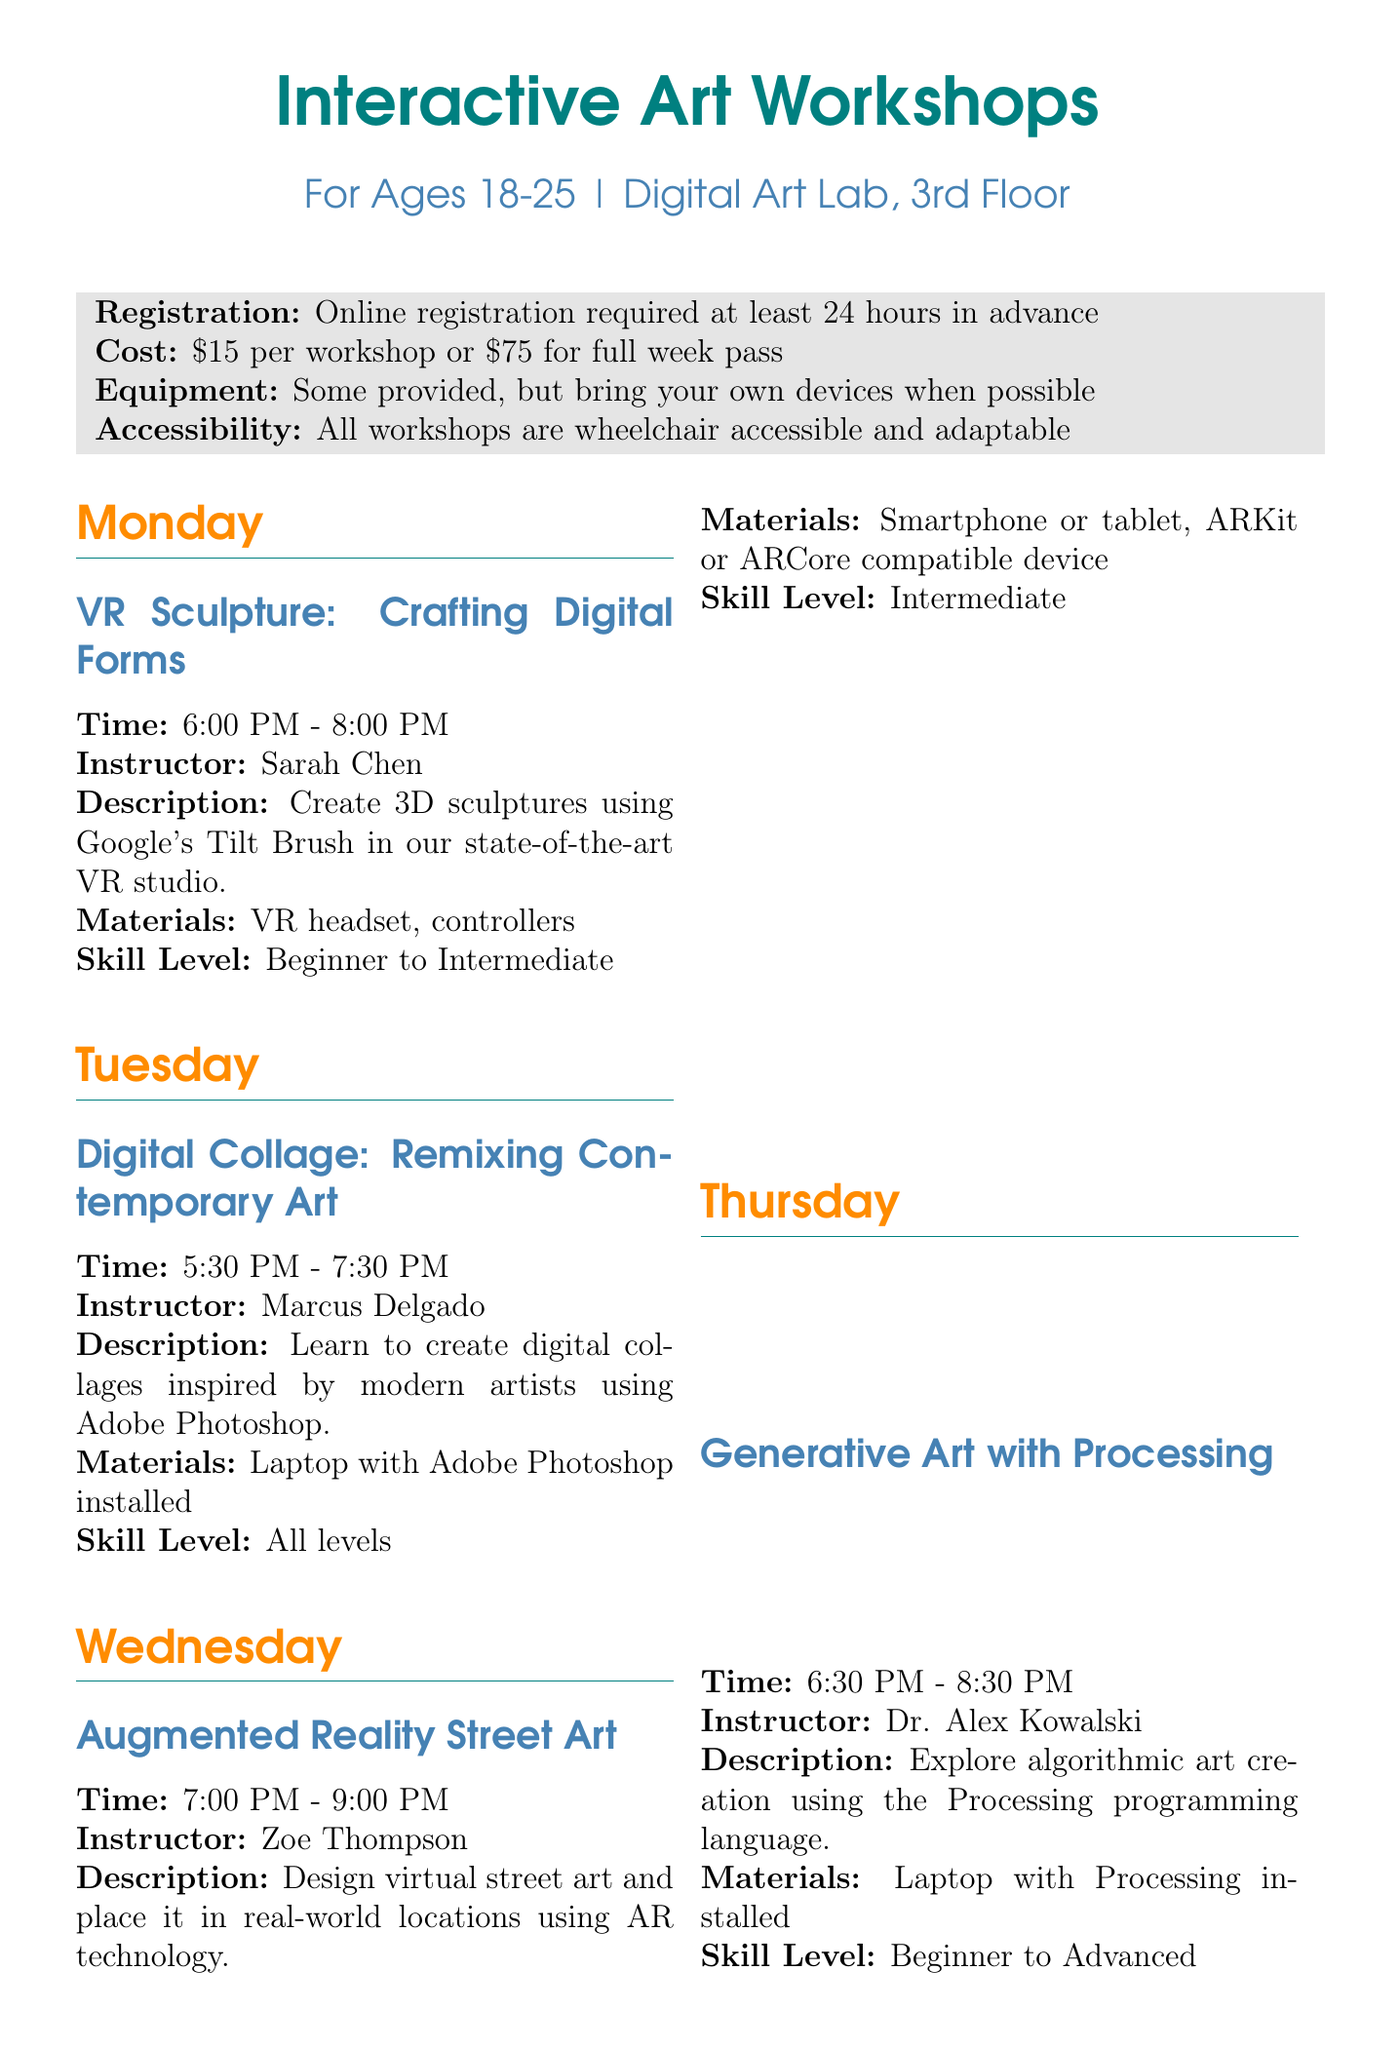what day is the VR sculpture workshop? The VR Sculpture workshop takes place on Monday according to the schedule.
Answer: Monday who is the instructor for the Digital Performance Art workshop? The instructor for the Digital Performance Art workshop is Jamal Washington as noted in the document.
Answer: Jamal Washington what is the cost of a full week pass? The cost of a full week pass is presented as $75 in the additional information.
Answer: $75 which workshop requires a smartphone or tablet? The workshop that requires a smartphone or tablet is Augmented Reality Street Art based on the materials needed listed.
Answer: Augmented Reality Street Art how many hours does the Interactive Installation Design workshop last? The duration of the Interactive Installation Design workshop is 2 hours, detailed in the time section.
Answer: 2 hours what is the minimum skill level for Generative Art with Processing? The minimum skill level for Generative Art with Processing is indicated as Beginner in the skill level section.
Answer: Beginner when is the Monthly VR Art Showcase held? The Monthly VR Art Showcase is held on the last Friday of every month according to the special events section.
Answer: Last Friday of every month which day features the Digital Art Market? The Digital Art Market takes place on the first Saturday of every month as specified in the special events.
Answer: First Saturday of every month 